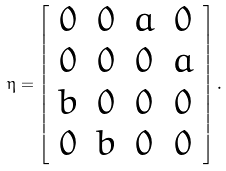<formula> <loc_0><loc_0><loc_500><loc_500>\eta = \left [ \begin{array} { c c c c } 0 & 0 & a & 0 \\ 0 & 0 & 0 & a \\ b & 0 & 0 & 0 \\ 0 & b & 0 & 0 \end{array} \right ] .</formula> 